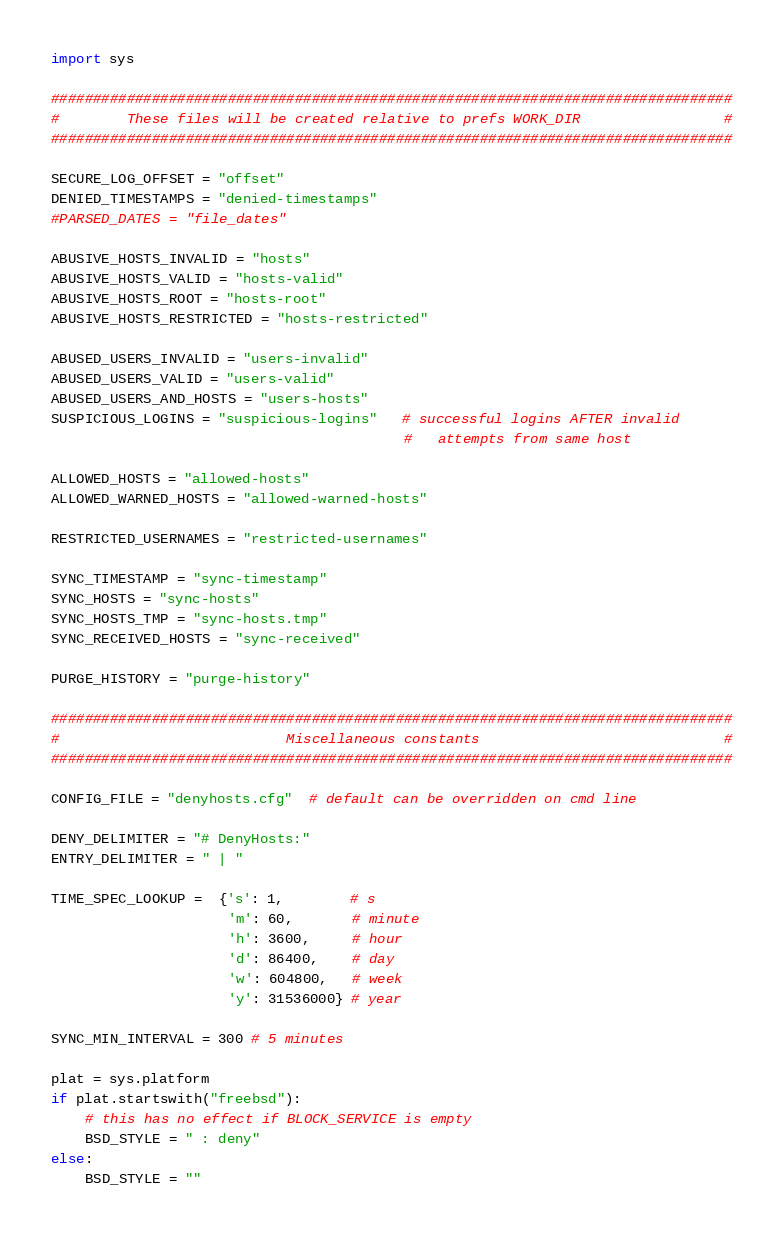<code> <loc_0><loc_0><loc_500><loc_500><_Python_>
import sys

#################################################################################
#        These files will be created relative to prefs WORK_DIR                 #
#################################################################################

SECURE_LOG_OFFSET = "offset"
DENIED_TIMESTAMPS = "denied-timestamps"
#PARSED_DATES = "file_dates"

ABUSIVE_HOSTS_INVALID = "hosts"
ABUSIVE_HOSTS_VALID = "hosts-valid"
ABUSIVE_HOSTS_ROOT = "hosts-root"
ABUSIVE_HOSTS_RESTRICTED = "hosts-restricted"

ABUSED_USERS_INVALID = "users-invalid"
ABUSED_USERS_VALID = "users-valid"
ABUSED_USERS_AND_HOSTS = "users-hosts"                              
SUSPICIOUS_LOGINS = "suspicious-logins"   # successful logins AFTER invalid
                                          #   attempts from same host

ALLOWED_HOSTS = "allowed-hosts"
ALLOWED_WARNED_HOSTS = "allowed-warned-hosts"

RESTRICTED_USERNAMES = "restricted-usernames"

SYNC_TIMESTAMP = "sync-timestamp"
SYNC_HOSTS = "sync-hosts"
SYNC_HOSTS_TMP = "sync-hosts.tmp"
SYNC_RECEIVED_HOSTS = "sync-received"

PURGE_HISTORY = "purge-history"

#################################################################################
#                           Miscellaneous constants                             #
#################################################################################

CONFIG_FILE = "denyhosts.cfg"  # default can be overridden on cmd line

DENY_DELIMITER = "# DenyHosts:"
ENTRY_DELIMITER = " | "

TIME_SPEC_LOOKUP =  {'s': 1,        # s
                     'm': 60,       # minute
                     'h': 3600,     # hour
                     'd': 86400,    # day
                     'w': 604800,   # week
                     'y': 31536000} # year

SYNC_MIN_INTERVAL = 300 # 5 minutes

plat = sys.platform
if plat.startswith("freebsd"):
    # this has no effect if BLOCK_SERVICE is empty
    BSD_STYLE = " : deny"
else:
    BSD_STYLE = ""

</code> 